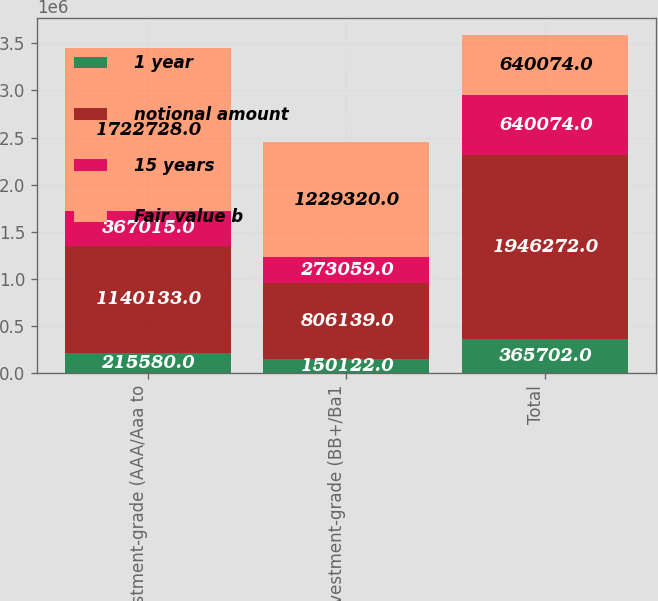Convert chart. <chart><loc_0><loc_0><loc_500><loc_500><stacked_bar_chart><ecel><fcel>Investment-grade (AAA/Aaa to<fcel>Noninvestment-grade (BB+/Ba1<fcel>Total<nl><fcel>1 year<fcel>215580<fcel>150122<fcel>365702<nl><fcel>notional amount<fcel>1.14013e+06<fcel>806139<fcel>1.94627e+06<nl><fcel>15 years<fcel>367015<fcel>273059<fcel>640074<nl><fcel>Fair value b<fcel>1.72273e+06<fcel>1.22932e+06<fcel>640074<nl></chart> 